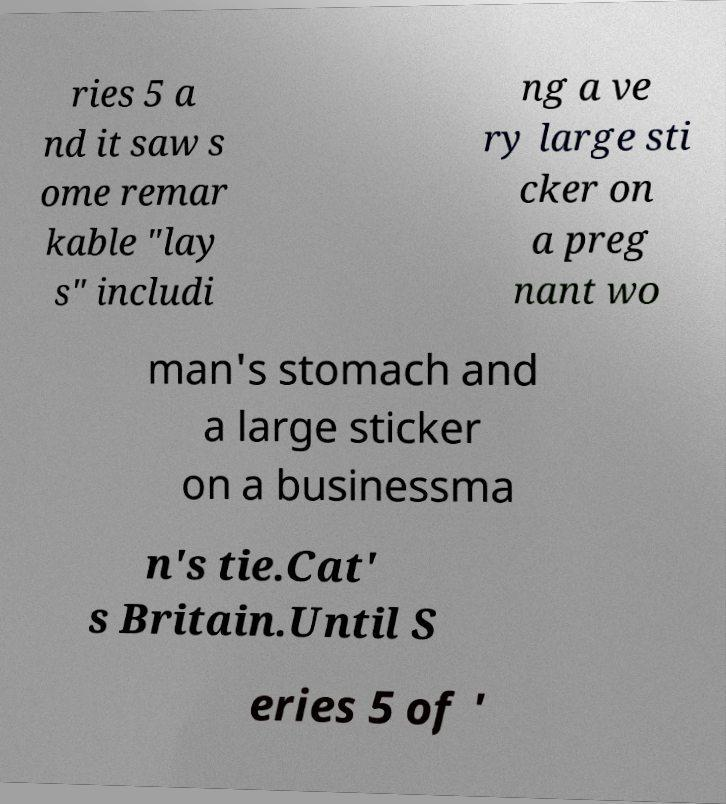Could you extract and type out the text from this image? ries 5 a nd it saw s ome remar kable "lay s" includi ng a ve ry large sti cker on a preg nant wo man's stomach and a large sticker on a businessma n's tie.Cat' s Britain.Until S eries 5 of ' 